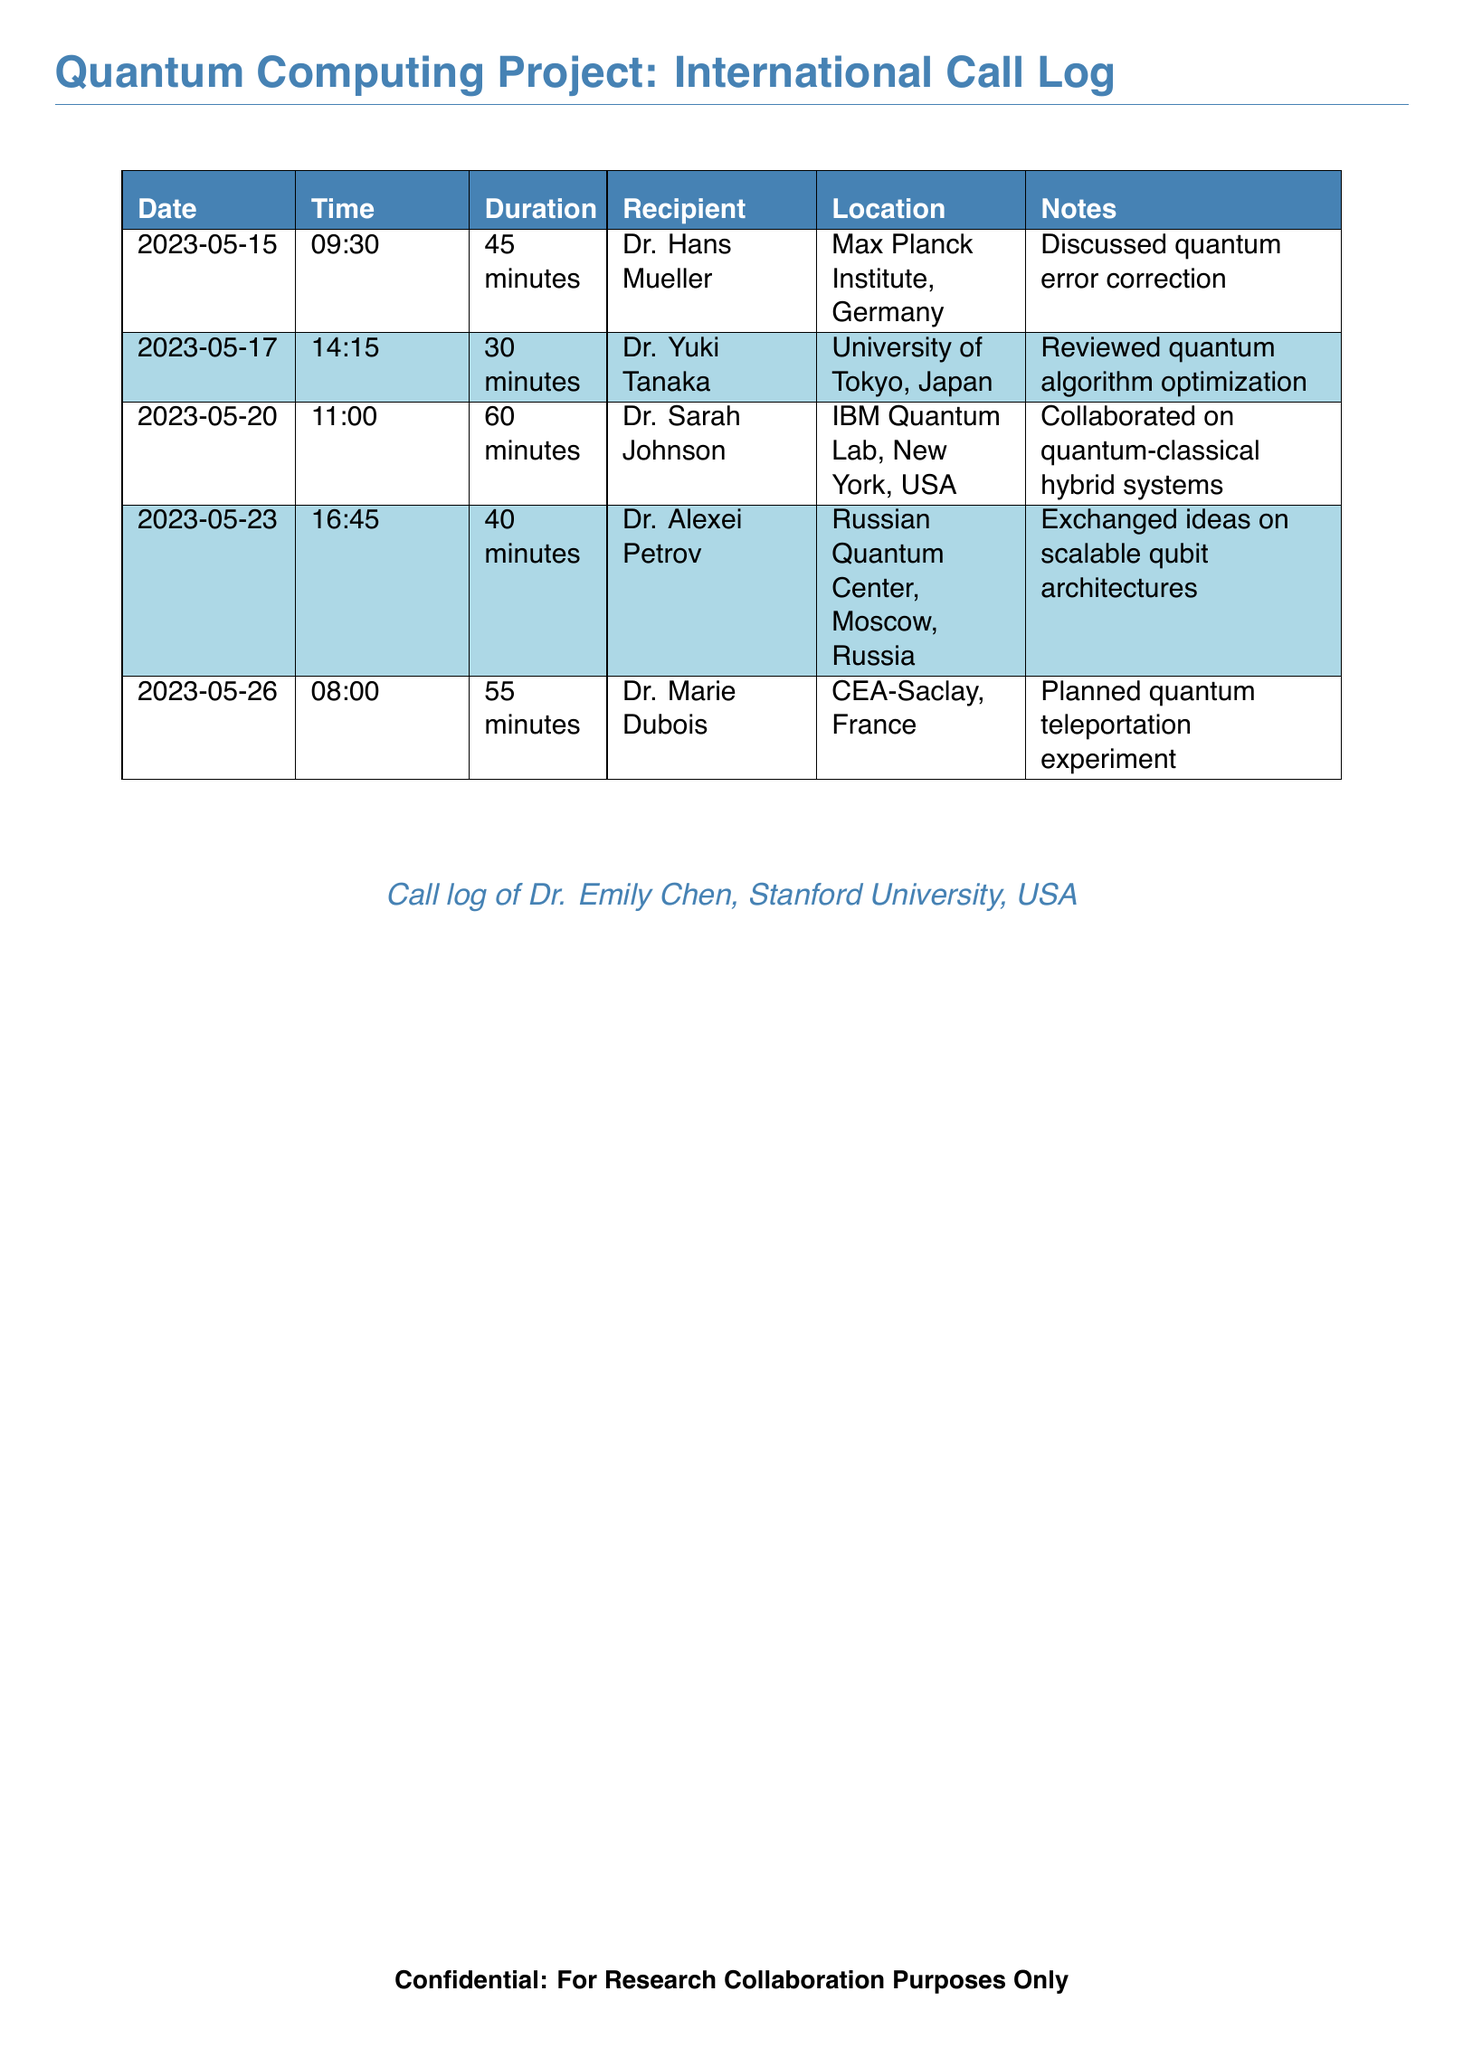What was the duration of the call with Dr. Hans Mueller? The duration of the call with Dr. Hans Mueller is specified in the document as 45 minutes.
Answer: 45 minutes Who collaborated on quantum-classical hybrid systems? The document states that Dr. Sarah Johnson collaborated on quantum-classical hybrid systems.
Answer: Dr. Sarah Johnson What is the location of Dr. Yuki Tanaka? The document lists the location of Dr. Yuki Tanaka as University of Tokyo, Japan.
Answer: University of Tokyo, Japan How many calls were made in May 2023? The document provides a total of five calls made in May 2023.
Answer: 5 What topic was discussed during the call with Dr. Marie Dubois? The call with Dr. Marie Dubois involved planning a quantum teleportation experiment.
Answer: Planned quantum teleportation experiment Which call had the longest duration? Referring to the duration of each call listed, the call with Dr. Sarah Johnson lasted the longest at 60 minutes.
Answer: 60 minutes What is the purpose of the document? The document specifies that it is for research collaboration purposes only.
Answer: For Research Collaboration Purposes Only Which researcher is affiliated with the Max Planck Institute? Dr. Hans Mueller is the researcher affiliated with the Max Planck Institute, as indicated in the document.
Answer: Dr. Hans Mueller 